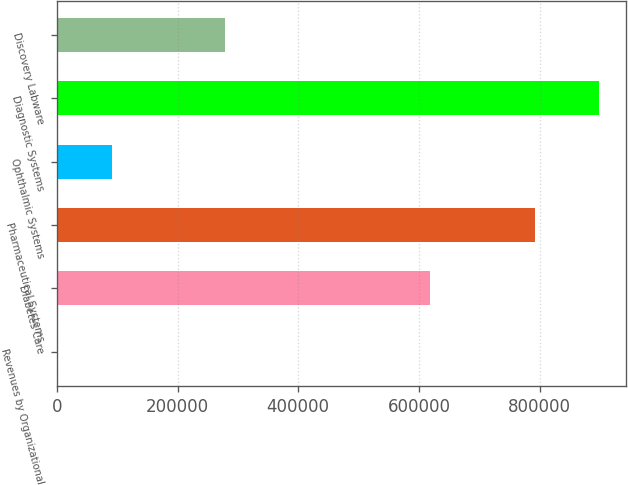Convert chart. <chart><loc_0><loc_0><loc_500><loc_500><bar_chart><fcel>Revenues by Organizational<fcel>Diabetes Care<fcel>Pharmaceutical Systems<fcel>Ophthalmic Systems<fcel>Diagnostic Systems<fcel>Discovery Labware<nl><fcel>2007<fcel>619108<fcel>791900<fcel>91647.6<fcel>898413<fcel>277902<nl></chart> 